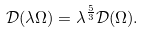<formula> <loc_0><loc_0><loc_500><loc_500>\mathcal { D } ( \lambda \Omega ) = \lambda ^ { \frac { 5 } { 3 } } \mathcal { D } ( \Omega ) .</formula> 